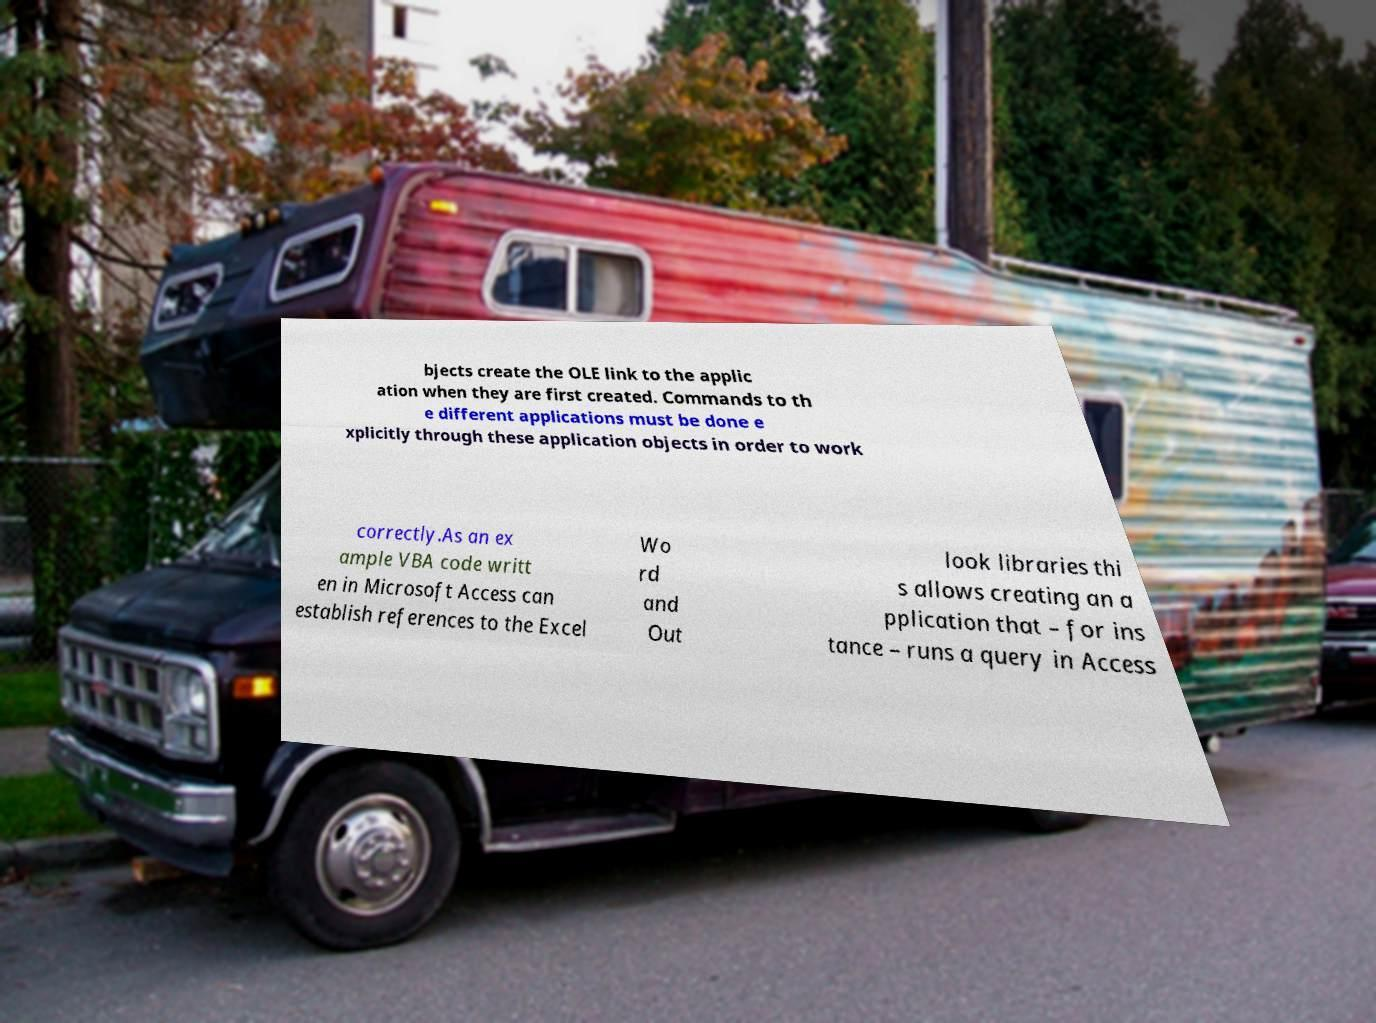What messages or text are displayed in this image? I need them in a readable, typed format. bjects create the OLE link to the applic ation when they are first created. Commands to th e different applications must be done e xplicitly through these application objects in order to work correctly.As an ex ample VBA code writt en in Microsoft Access can establish references to the Excel Wo rd and Out look libraries thi s allows creating an a pplication that – for ins tance – runs a query in Access 